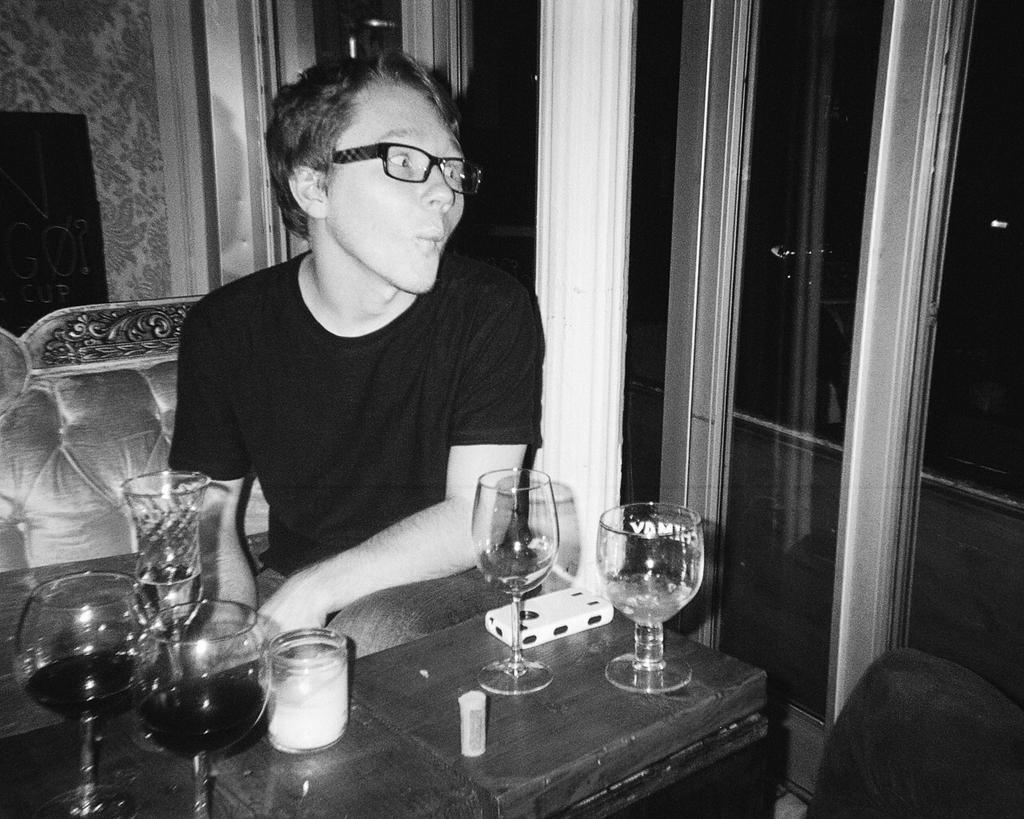What is the person in the image doing? There is a person sitting in the image. What objects are on the table in the image? There are many glasses on a table in the image. What type of windows can be seen in the background of the image? There are glass windows in the background of the image. What type of prose is the person reading in the image? There is no indication in the image that the person is reading any prose, as the person is simply sitting and no reading material is visible. 